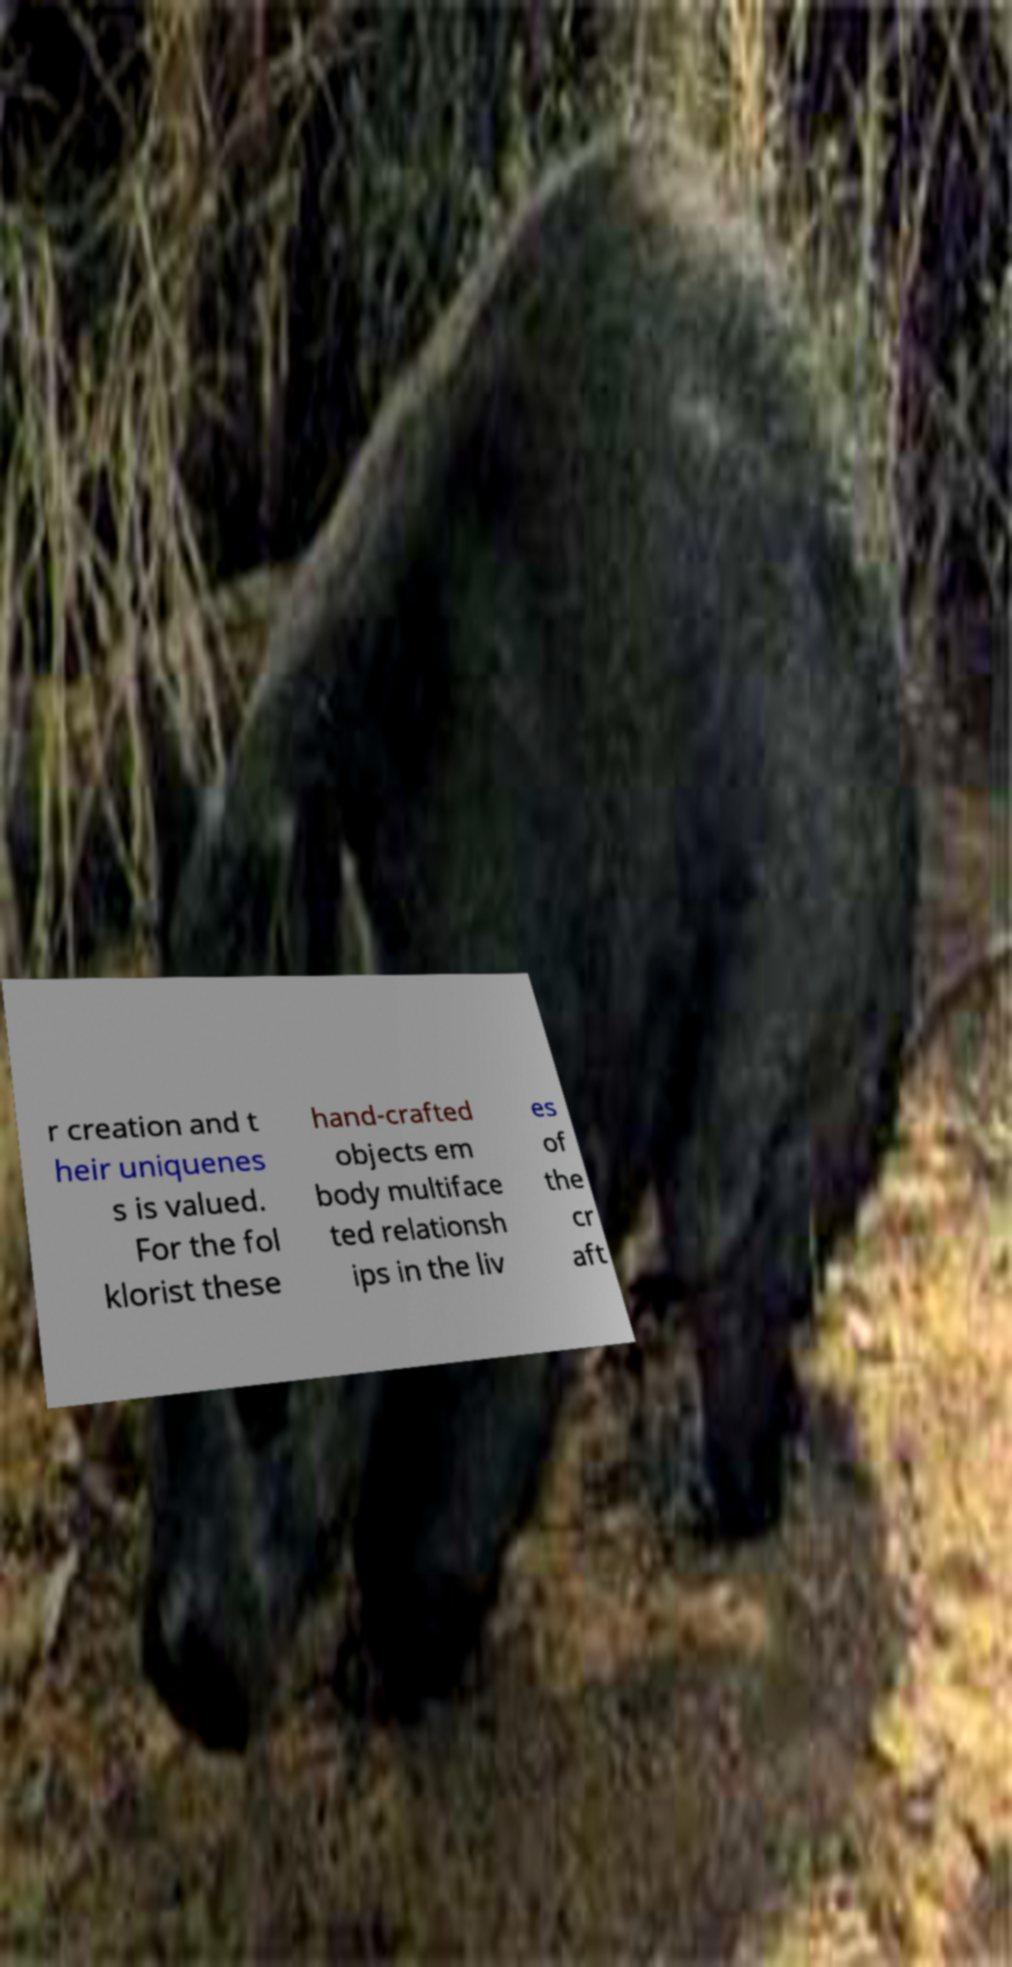I need the written content from this picture converted into text. Can you do that? r creation and t heir uniquenes s is valued. For the fol klorist these hand-crafted objects em body multiface ted relationsh ips in the liv es of the cr aft 